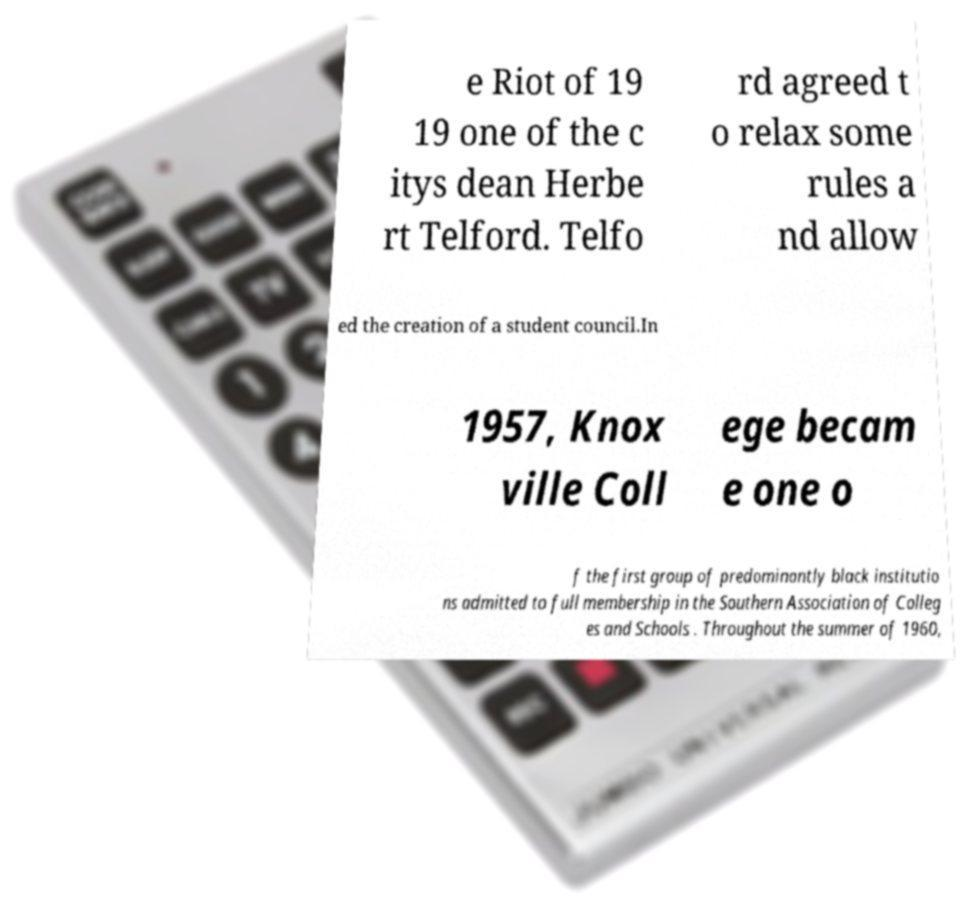For documentation purposes, I need the text within this image transcribed. Could you provide that? e Riot of 19 19 one of the c itys dean Herbe rt Telford. Telfo rd agreed t o relax some rules a nd allow ed the creation of a student council.In 1957, Knox ville Coll ege becam e one o f the first group of predominantly black institutio ns admitted to full membership in the Southern Association of Colleg es and Schools . Throughout the summer of 1960, 